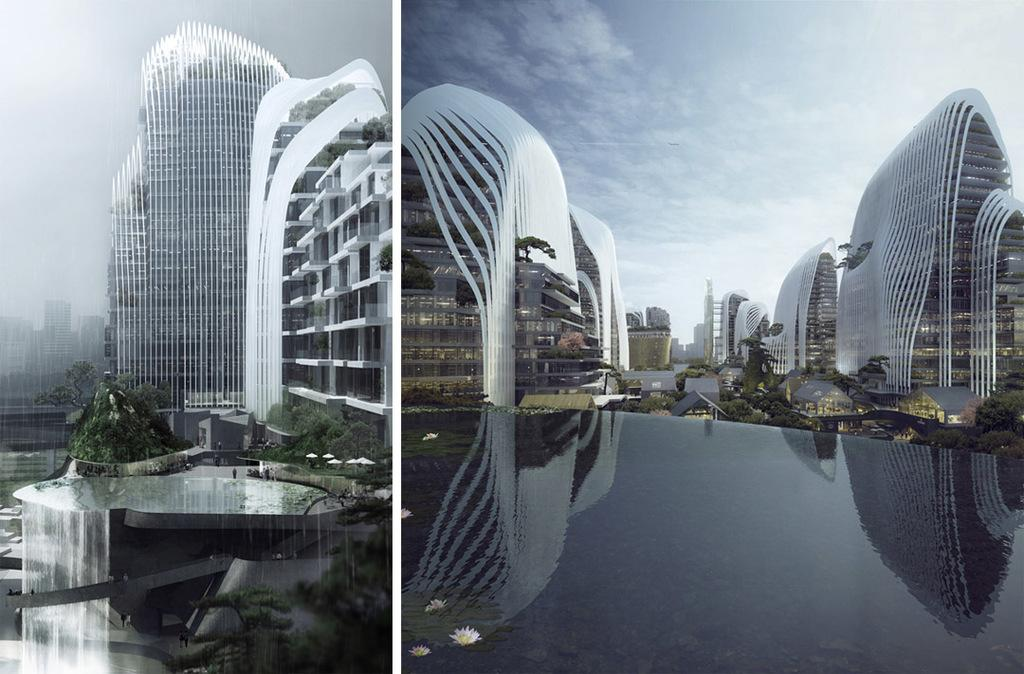What type of artwork is the image? The image is a collage. What structures are present in the collage? There are buildings in the image. What type of vegetation is included in the collage? There are trees in the image. What natural element can be seen in the collage? There is water visible in the image. What is visible in the sky at the top of the collage? There are clouds in the sky at the top of the image. What type of advice does the minister give in the image? There is no minister present in the image, so it is not possible to answer that question. 